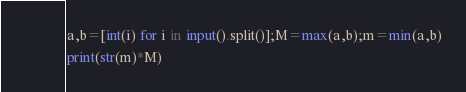Convert code to text. <code><loc_0><loc_0><loc_500><loc_500><_Python_>a,b=[int(i) for i in input().split()];M=max(a,b);m=min(a,b)
print(str(m)*M)</code> 